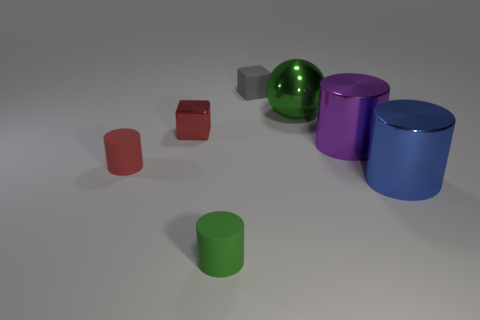Add 1 large green balls. How many objects exist? 8 Subtract all tiny green cylinders. How many cylinders are left? 3 Subtract all gray cubes. How many cubes are left? 1 Subtract all blue cubes. Subtract all gray cylinders. How many cubes are left? 2 Subtract all brown spheres. Subtract all tiny rubber things. How many objects are left? 4 Add 1 big metal things. How many big metal things are left? 4 Add 1 red cylinders. How many red cylinders exist? 2 Subtract 1 green cylinders. How many objects are left? 6 Subtract all balls. How many objects are left? 6 Subtract 2 cubes. How many cubes are left? 0 